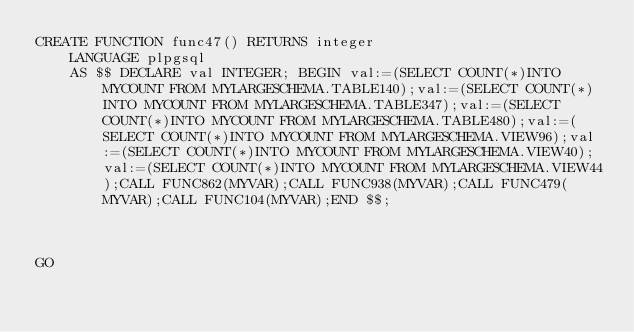<code> <loc_0><loc_0><loc_500><loc_500><_SQL_>CREATE FUNCTION func47() RETURNS integer
    LANGUAGE plpgsql
    AS $$ DECLARE val INTEGER; BEGIN val:=(SELECT COUNT(*)INTO MYCOUNT FROM MYLARGESCHEMA.TABLE140);val:=(SELECT COUNT(*)INTO MYCOUNT FROM MYLARGESCHEMA.TABLE347);val:=(SELECT COUNT(*)INTO MYCOUNT FROM MYLARGESCHEMA.TABLE480);val:=(SELECT COUNT(*)INTO MYCOUNT FROM MYLARGESCHEMA.VIEW96);val:=(SELECT COUNT(*)INTO MYCOUNT FROM MYLARGESCHEMA.VIEW40);val:=(SELECT COUNT(*)INTO MYCOUNT FROM MYLARGESCHEMA.VIEW44);CALL FUNC862(MYVAR);CALL FUNC938(MYVAR);CALL FUNC479(MYVAR);CALL FUNC104(MYVAR);END $$;



GO</code> 